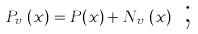<formula> <loc_0><loc_0><loc_500><loc_500>P _ { v _ { r } } ( x ) = P ( x ) + N _ { v _ { r } } ( x ) \text { ;}</formula> 